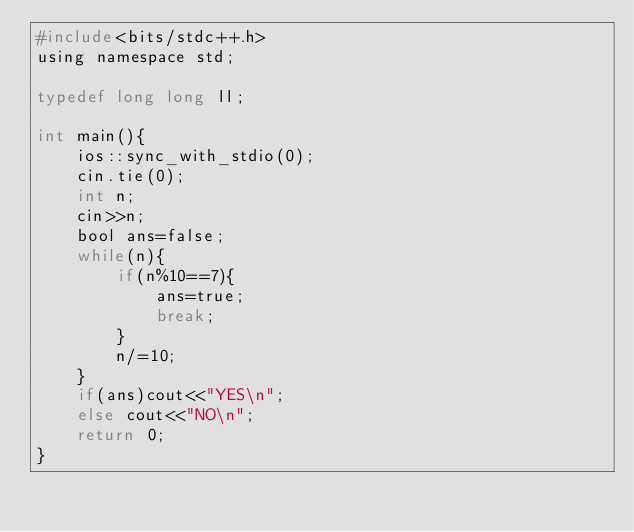Convert code to text. <code><loc_0><loc_0><loc_500><loc_500><_C_>#include<bits/stdc++.h>
using namespace std;

typedef long long ll;

int main(){
    ios::sync_with_stdio(0);
    cin.tie(0);
    int n;
    cin>>n;
    bool ans=false;
    while(n){
        if(n%10==7){
            ans=true;
            break;
        }
        n/=10;
    }
    if(ans)cout<<"YES\n";
    else cout<<"NO\n";
    return 0;
}
</code> 